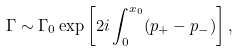<formula> <loc_0><loc_0><loc_500><loc_500>\Gamma \sim \Gamma _ { 0 } \exp \left [ 2 i \int _ { 0 } ^ { x _ { 0 } } ( p _ { + } - p _ { - } ) \right ] ,</formula> 